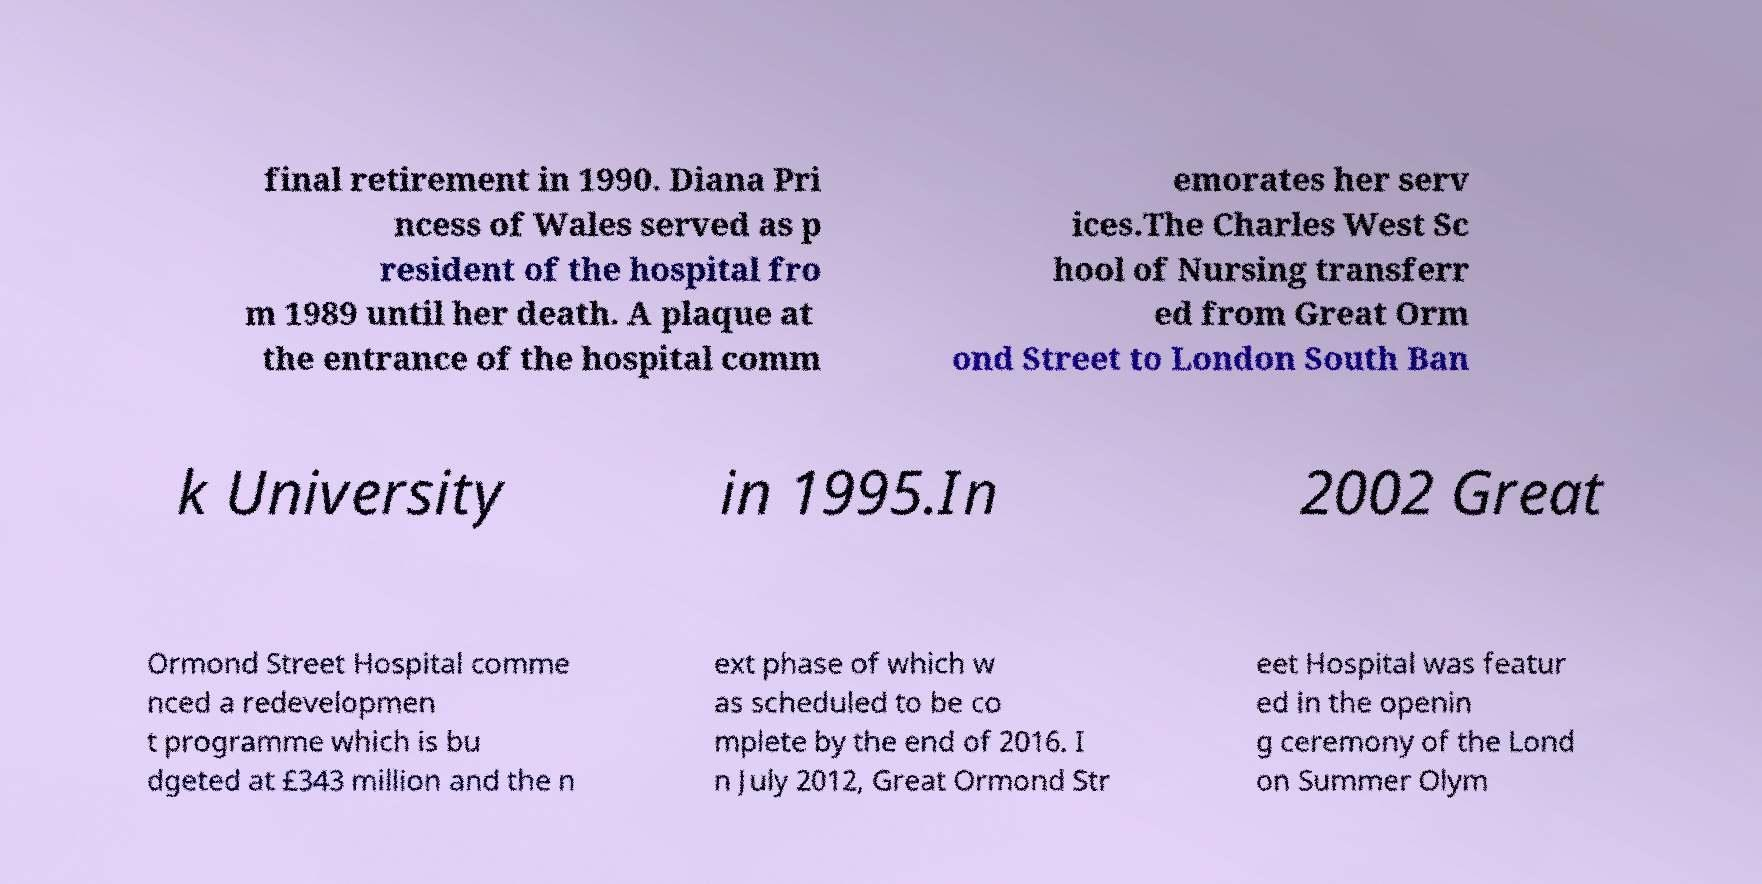I need the written content from this picture converted into text. Can you do that? final retirement in 1990. Diana Pri ncess of Wales served as p resident of the hospital fro m 1989 until her death. A plaque at the entrance of the hospital comm emorates her serv ices.The Charles West Sc hool of Nursing transferr ed from Great Orm ond Street to London South Ban k University in 1995.In 2002 Great Ormond Street Hospital comme nced a redevelopmen t programme which is bu dgeted at £343 million and the n ext phase of which w as scheduled to be co mplete by the end of 2016. I n July 2012, Great Ormond Str eet Hospital was featur ed in the openin g ceremony of the Lond on Summer Olym 